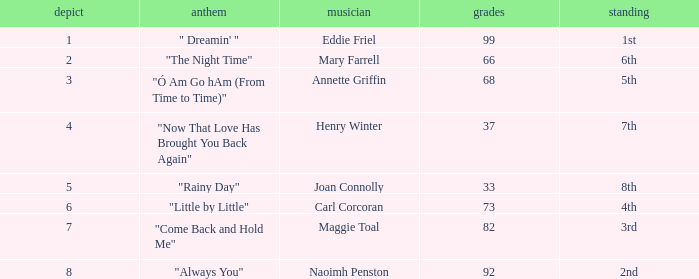When ranked 7th and having a draw under 4 points, what is the typical point total? None. 